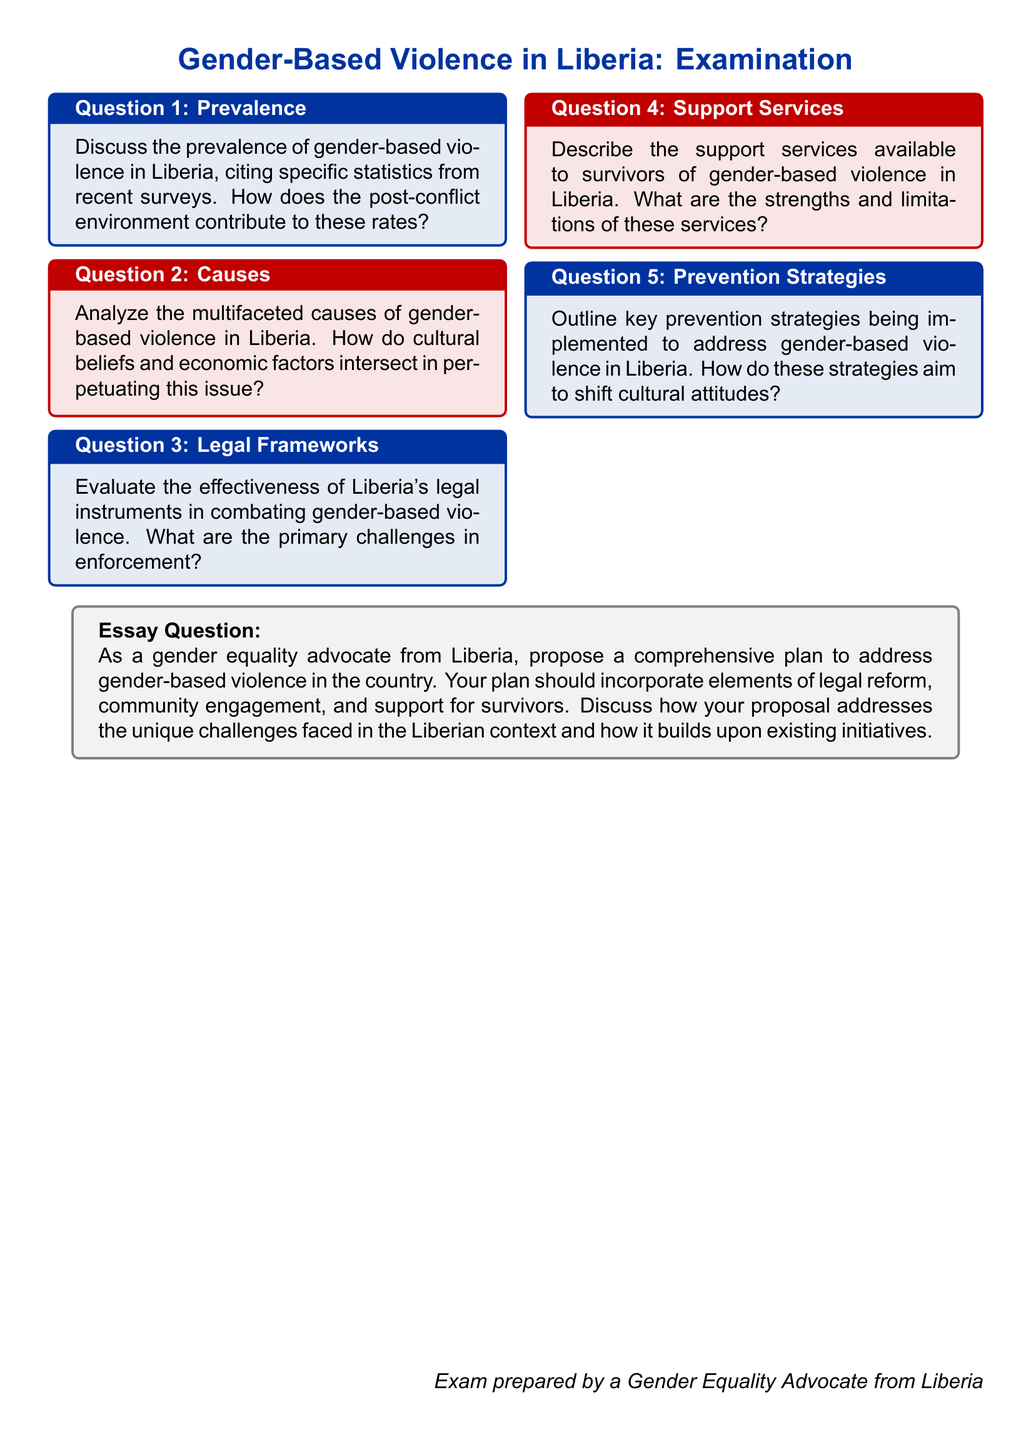What is the title of the document? The title of the document is found in the center at the beginning, presenting the main topic of examination.
Answer: Gender-Based Violence in Liberia: Examination How many main questions are included in the document? The document outlines a total of five main questions addressing various aspects of gender-based violence.
Answer: Five What color is used for the box containing Question 3? The color used for Question 3 is specified in the formatting options, indicating the visual representation for this part.
Answer: Liberiablue What is the focus of the essay question in the document? The essay question requires a detailed proposal addressing gender-based violence, integrating various elements as outlined.
Answer: Comprehensive plan to address gender-based violence What aspect of gender-based violence does Question 4 address? This question specifically discusses the available support services for survivors of gender-based violence in Liberia.
Answer: Support services What is a primary challenge in enforcing legal instruments mentioned in the document? The challenge in enforcing legal instruments is highlighted as a significant issue in combating gender-based violence within the context.
Answer: Enforcement challenges 